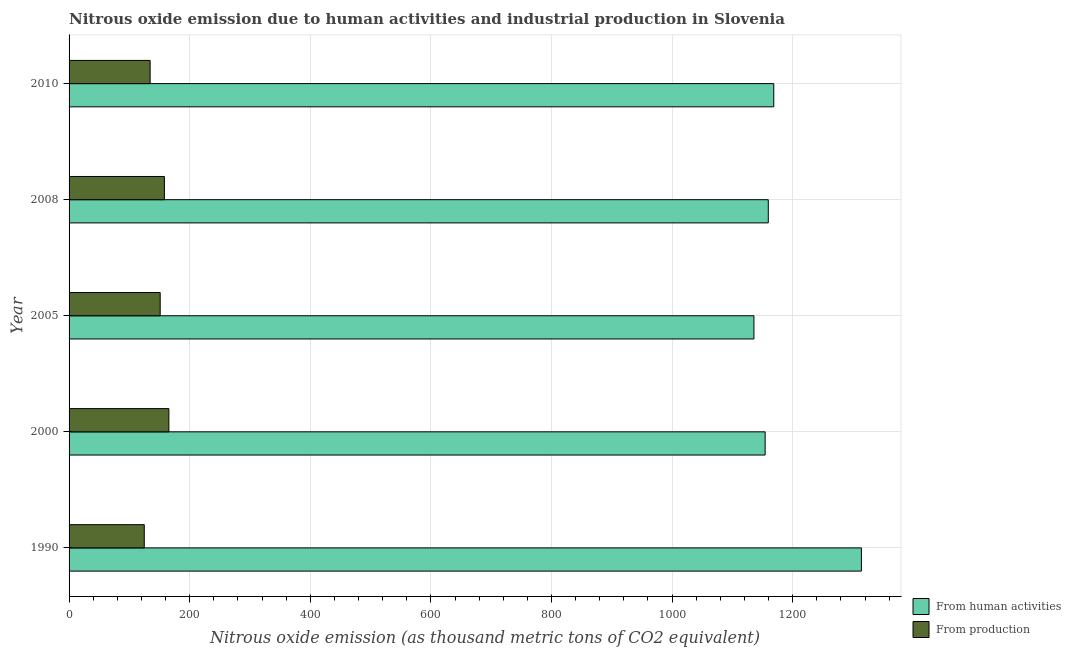How many groups of bars are there?
Provide a short and direct response. 5. In how many cases, is the number of bars for a given year not equal to the number of legend labels?
Offer a very short reply. 0. What is the amount of emissions from human activities in 2008?
Your response must be concise. 1159.5. Across all years, what is the maximum amount of emissions from human activities?
Make the answer very short. 1313.9. Across all years, what is the minimum amount of emissions from human activities?
Provide a succinct answer. 1135.7. In which year was the amount of emissions generated from industries maximum?
Keep it short and to the point. 2000. What is the total amount of emissions from human activities in the graph?
Make the answer very short. 5932. What is the difference between the amount of emissions generated from industries in 2005 and the amount of emissions from human activities in 1990?
Provide a succinct answer. -1162.8. What is the average amount of emissions generated from industries per year?
Provide a succinct answer. 146.76. In the year 1990, what is the difference between the amount of emissions generated from industries and amount of emissions from human activities?
Make the answer very short. -1189.2. In how many years, is the amount of emissions from human activities greater than 520 thousand metric tons?
Offer a terse response. 5. What is the ratio of the amount of emissions from human activities in 2000 to that in 2010?
Offer a very short reply. 0.99. Is the difference between the amount of emissions generated from industries in 2000 and 2010 greater than the difference between the amount of emissions from human activities in 2000 and 2010?
Your answer should be very brief. Yes. What is the difference between the highest and the second highest amount of emissions from human activities?
Keep it short and to the point. 145.3. What is the difference between the highest and the lowest amount of emissions from human activities?
Make the answer very short. 178.2. What does the 2nd bar from the top in 1990 represents?
Offer a very short reply. From human activities. What does the 2nd bar from the bottom in 2005 represents?
Your answer should be compact. From production. How many bars are there?
Keep it short and to the point. 10. What is the difference between two consecutive major ticks on the X-axis?
Give a very brief answer. 200. Are the values on the major ticks of X-axis written in scientific E-notation?
Your answer should be very brief. No. Does the graph contain grids?
Keep it short and to the point. Yes. Where does the legend appear in the graph?
Ensure brevity in your answer.  Bottom right. How are the legend labels stacked?
Offer a terse response. Vertical. What is the title of the graph?
Provide a succinct answer. Nitrous oxide emission due to human activities and industrial production in Slovenia. Does "Money lenders" appear as one of the legend labels in the graph?
Ensure brevity in your answer.  No. What is the label or title of the X-axis?
Offer a very short reply. Nitrous oxide emission (as thousand metric tons of CO2 equivalent). What is the label or title of the Y-axis?
Your response must be concise. Year. What is the Nitrous oxide emission (as thousand metric tons of CO2 equivalent) of From human activities in 1990?
Your response must be concise. 1313.9. What is the Nitrous oxide emission (as thousand metric tons of CO2 equivalent) of From production in 1990?
Provide a short and direct response. 124.7. What is the Nitrous oxide emission (as thousand metric tons of CO2 equivalent) in From human activities in 2000?
Give a very brief answer. 1154.3. What is the Nitrous oxide emission (as thousand metric tons of CO2 equivalent) in From production in 2000?
Keep it short and to the point. 165.5. What is the Nitrous oxide emission (as thousand metric tons of CO2 equivalent) of From human activities in 2005?
Provide a short and direct response. 1135.7. What is the Nitrous oxide emission (as thousand metric tons of CO2 equivalent) in From production in 2005?
Your response must be concise. 151.1. What is the Nitrous oxide emission (as thousand metric tons of CO2 equivalent) of From human activities in 2008?
Make the answer very short. 1159.5. What is the Nitrous oxide emission (as thousand metric tons of CO2 equivalent) of From production in 2008?
Give a very brief answer. 158.1. What is the Nitrous oxide emission (as thousand metric tons of CO2 equivalent) in From human activities in 2010?
Make the answer very short. 1168.6. What is the Nitrous oxide emission (as thousand metric tons of CO2 equivalent) of From production in 2010?
Your answer should be very brief. 134.4. Across all years, what is the maximum Nitrous oxide emission (as thousand metric tons of CO2 equivalent) in From human activities?
Your response must be concise. 1313.9. Across all years, what is the maximum Nitrous oxide emission (as thousand metric tons of CO2 equivalent) in From production?
Give a very brief answer. 165.5. Across all years, what is the minimum Nitrous oxide emission (as thousand metric tons of CO2 equivalent) in From human activities?
Your response must be concise. 1135.7. Across all years, what is the minimum Nitrous oxide emission (as thousand metric tons of CO2 equivalent) of From production?
Keep it short and to the point. 124.7. What is the total Nitrous oxide emission (as thousand metric tons of CO2 equivalent) in From human activities in the graph?
Your answer should be very brief. 5932. What is the total Nitrous oxide emission (as thousand metric tons of CO2 equivalent) in From production in the graph?
Ensure brevity in your answer.  733.8. What is the difference between the Nitrous oxide emission (as thousand metric tons of CO2 equivalent) in From human activities in 1990 and that in 2000?
Your answer should be compact. 159.6. What is the difference between the Nitrous oxide emission (as thousand metric tons of CO2 equivalent) in From production in 1990 and that in 2000?
Provide a succinct answer. -40.8. What is the difference between the Nitrous oxide emission (as thousand metric tons of CO2 equivalent) of From human activities in 1990 and that in 2005?
Give a very brief answer. 178.2. What is the difference between the Nitrous oxide emission (as thousand metric tons of CO2 equivalent) in From production in 1990 and that in 2005?
Offer a terse response. -26.4. What is the difference between the Nitrous oxide emission (as thousand metric tons of CO2 equivalent) of From human activities in 1990 and that in 2008?
Your response must be concise. 154.4. What is the difference between the Nitrous oxide emission (as thousand metric tons of CO2 equivalent) of From production in 1990 and that in 2008?
Your answer should be compact. -33.4. What is the difference between the Nitrous oxide emission (as thousand metric tons of CO2 equivalent) of From human activities in 1990 and that in 2010?
Your answer should be very brief. 145.3. What is the difference between the Nitrous oxide emission (as thousand metric tons of CO2 equivalent) of From production in 1990 and that in 2010?
Offer a terse response. -9.7. What is the difference between the Nitrous oxide emission (as thousand metric tons of CO2 equivalent) of From human activities in 2000 and that in 2005?
Your answer should be very brief. 18.6. What is the difference between the Nitrous oxide emission (as thousand metric tons of CO2 equivalent) of From production in 2000 and that in 2005?
Ensure brevity in your answer.  14.4. What is the difference between the Nitrous oxide emission (as thousand metric tons of CO2 equivalent) in From production in 2000 and that in 2008?
Offer a terse response. 7.4. What is the difference between the Nitrous oxide emission (as thousand metric tons of CO2 equivalent) of From human activities in 2000 and that in 2010?
Your answer should be compact. -14.3. What is the difference between the Nitrous oxide emission (as thousand metric tons of CO2 equivalent) of From production in 2000 and that in 2010?
Provide a succinct answer. 31.1. What is the difference between the Nitrous oxide emission (as thousand metric tons of CO2 equivalent) in From human activities in 2005 and that in 2008?
Provide a succinct answer. -23.8. What is the difference between the Nitrous oxide emission (as thousand metric tons of CO2 equivalent) in From human activities in 2005 and that in 2010?
Ensure brevity in your answer.  -32.9. What is the difference between the Nitrous oxide emission (as thousand metric tons of CO2 equivalent) of From production in 2005 and that in 2010?
Give a very brief answer. 16.7. What is the difference between the Nitrous oxide emission (as thousand metric tons of CO2 equivalent) in From production in 2008 and that in 2010?
Give a very brief answer. 23.7. What is the difference between the Nitrous oxide emission (as thousand metric tons of CO2 equivalent) in From human activities in 1990 and the Nitrous oxide emission (as thousand metric tons of CO2 equivalent) in From production in 2000?
Your answer should be very brief. 1148.4. What is the difference between the Nitrous oxide emission (as thousand metric tons of CO2 equivalent) of From human activities in 1990 and the Nitrous oxide emission (as thousand metric tons of CO2 equivalent) of From production in 2005?
Your response must be concise. 1162.8. What is the difference between the Nitrous oxide emission (as thousand metric tons of CO2 equivalent) of From human activities in 1990 and the Nitrous oxide emission (as thousand metric tons of CO2 equivalent) of From production in 2008?
Provide a short and direct response. 1155.8. What is the difference between the Nitrous oxide emission (as thousand metric tons of CO2 equivalent) in From human activities in 1990 and the Nitrous oxide emission (as thousand metric tons of CO2 equivalent) in From production in 2010?
Offer a very short reply. 1179.5. What is the difference between the Nitrous oxide emission (as thousand metric tons of CO2 equivalent) in From human activities in 2000 and the Nitrous oxide emission (as thousand metric tons of CO2 equivalent) in From production in 2005?
Offer a very short reply. 1003.2. What is the difference between the Nitrous oxide emission (as thousand metric tons of CO2 equivalent) in From human activities in 2000 and the Nitrous oxide emission (as thousand metric tons of CO2 equivalent) in From production in 2008?
Offer a very short reply. 996.2. What is the difference between the Nitrous oxide emission (as thousand metric tons of CO2 equivalent) in From human activities in 2000 and the Nitrous oxide emission (as thousand metric tons of CO2 equivalent) in From production in 2010?
Give a very brief answer. 1019.9. What is the difference between the Nitrous oxide emission (as thousand metric tons of CO2 equivalent) of From human activities in 2005 and the Nitrous oxide emission (as thousand metric tons of CO2 equivalent) of From production in 2008?
Provide a short and direct response. 977.6. What is the difference between the Nitrous oxide emission (as thousand metric tons of CO2 equivalent) in From human activities in 2005 and the Nitrous oxide emission (as thousand metric tons of CO2 equivalent) in From production in 2010?
Keep it short and to the point. 1001.3. What is the difference between the Nitrous oxide emission (as thousand metric tons of CO2 equivalent) in From human activities in 2008 and the Nitrous oxide emission (as thousand metric tons of CO2 equivalent) in From production in 2010?
Offer a terse response. 1025.1. What is the average Nitrous oxide emission (as thousand metric tons of CO2 equivalent) in From human activities per year?
Offer a terse response. 1186.4. What is the average Nitrous oxide emission (as thousand metric tons of CO2 equivalent) in From production per year?
Your answer should be very brief. 146.76. In the year 1990, what is the difference between the Nitrous oxide emission (as thousand metric tons of CO2 equivalent) of From human activities and Nitrous oxide emission (as thousand metric tons of CO2 equivalent) of From production?
Offer a terse response. 1189.2. In the year 2000, what is the difference between the Nitrous oxide emission (as thousand metric tons of CO2 equivalent) in From human activities and Nitrous oxide emission (as thousand metric tons of CO2 equivalent) in From production?
Provide a succinct answer. 988.8. In the year 2005, what is the difference between the Nitrous oxide emission (as thousand metric tons of CO2 equivalent) of From human activities and Nitrous oxide emission (as thousand metric tons of CO2 equivalent) of From production?
Provide a short and direct response. 984.6. In the year 2008, what is the difference between the Nitrous oxide emission (as thousand metric tons of CO2 equivalent) in From human activities and Nitrous oxide emission (as thousand metric tons of CO2 equivalent) in From production?
Provide a succinct answer. 1001.4. In the year 2010, what is the difference between the Nitrous oxide emission (as thousand metric tons of CO2 equivalent) of From human activities and Nitrous oxide emission (as thousand metric tons of CO2 equivalent) of From production?
Give a very brief answer. 1034.2. What is the ratio of the Nitrous oxide emission (as thousand metric tons of CO2 equivalent) in From human activities in 1990 to that in 2000?
Provide a short and direct response. 1.14. What is the ratio of the Nitrous oxide emission (as thousand metric tons of CO2 equivalent) in From production in 1990 to that in 2000?
Your response must be concise. 0.75. What is the ratio of the Nitrous oxide emission (as thousand metric tons of CO2 equivalent) of From human activities in 1990 to that in 2005?
Provide a succinct answer. 1.16. What is the ratio of the Nitrous oxide emission (as thousand metric tons of CO2 equivalent) of From production in 1990 to that in 2005?
Provide a short and direct response. 0.83. What is the ratio of the Nitrous oxide emission (as thousand metric tons of CO2 equivalent) of From human activities in 1990 to that in 2008?
Give a very brief answer. 1.13. What is the ratio of the Nitrous oxide emission (as thousand metric tons of CO2 equivalent) of From production in 1990 to that in 2008?
Your answer should be very brief. 0.79. What is the ratio of the Nitrous oxide emission (as thousand metric tons of CO2 equivalent) in From human activities in 1990 to that in 2010?
Provide a short and direct response. 1.12. What is the ratio of the Nitrous oxide emission (as thousand metric tons of CO2 equivalent) in From production in 1990 to that in 2010?
Make the answer very short. 0.93. What is the ratio of the Nitrous oxide emission (as thousand metric tons of CO2 equivalent) of From human activities in 2000 to that in 2005?
Your response must be concise. 1.02. What is the ratio of the Nitrous oxide emission (as thousand metric tons of CO2 equivalent) of From production in 2000 to that in 2005?
Offer a very short reply. 1.1. What is the ratio of the Nitrous oxide emission (as thousand metric tons of CO2 equivalent) in From production in 2000 to that in 2008?
Offer a very short reply. 1.05. What is the ratio of the Nitrous oxide emission (as thousand metric tons of CO2 equivalent) of From production in 2000 to that in 2010?
Offer a terse response. 1.23. What is the ratio of the Nitrous oxide emission (as thousand metric tons of CO2 equivalent) of From human activities in 2005 to that in 2008?
Your answer should be very brief. 0.98. What is the ratio of the Nitrous oxide emission (as thousand metric tons of CO2 equivalent) of From production in 2005 to that in 2008?
Keep it short and to the point. 0.96. What is the ratio of the Nitrous oxide emission (as thousand metric tons of CO2 equivalent) in From human activities in 2005 to that in 2010?
Ensure brevity in your answer.  0.97. What is the ratio of the Nitrous oxide emission (as thousand metric tons of CO2 equivalent) in From production in 2005 to that in 2010?
Offer a terse response. 1.12. What is the ratio of the Nitrous oxide emission (as thousand metric tons of CO2 equivalent) of From human activities in 2008 to that in 2010?
Your answer should be compact. 0.99. What is the ratio of the Nitrous oxide emission (as thousand metric tons of CO2 equivalent) of From production in 2008 to that in 2010?
Ensure brevity in your answer.  1.18. What is the difference between the highest and the second highest Nitrous oxide emission (as thousand metric tons of CO2 equivalent) in From human activities?
Offer a terse response. 145.3. What is the difference between the highest and the second highest Nitrous oxide emission (as thousand metric tons of CO2 equivalent) of From production?
Provide a succinct answer. 7.4. What is the difference between the highest and the lowest Nitrous oxide emission (as thousand metric tons of CO2 equivalent) in From human activities?
Provide a short and direct response. 178.2. What is the difference between the highest and the lowest Nitrous oxide emission (as thousand metric tons of CO2 equivalent) of From production?
Your answer should be very brief. 40.8. 